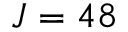Convert formula to latex. <formula><loc_0><loc_0><loc_500><loc_500>J = 4 8</formula> 